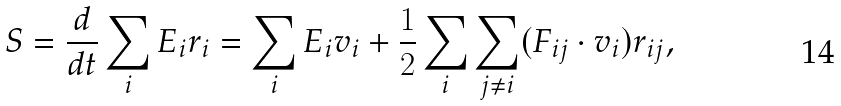Convert formula to latex. <formula><loc_0><loc_0><loc_500><loc_500>S = \frac { d } { d t } \sum _ { i } E _ { i } r _ { i } = \sum _ { i } E _ { i } v _ { i } + \frac { 1 } { 2 } \sum _ { i } \sum _ { j \ne i } ( F _ { i j } \cdot v _ { i } ) r _ { i j } ,</formula> 